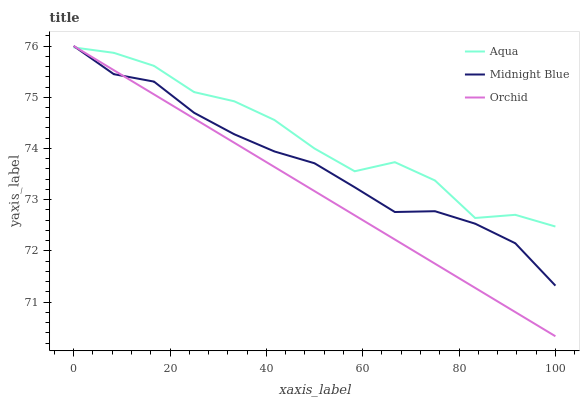Does Orchid have the minimum area under the curve?
Answer yes or no. Yes. Does Aqua have the maximum area under the curve?
Answer yes or no. Yes. Does Midnight Blue have the minimum area under the curve?
Answer yes or no. No. Does Midnight Blue have the maximum area under the curve?
Answer yes or no. No. Is Orchid the smoothest?
Answer yes or no. Yes. Is Aqua the roughest?
Answer yes or no. Yes. Is Midnight Blue the smoothest?
Answer yes or no. No. Is Midnight Blue the roughest?
Answer yes or no. No. Does Orchid have the lowest value?
Answer yes or no. Yes. Does Midnight Blue have the lowest value?
Answer yes or no. No. Does Orchid have the highest value?
Answer yes or no. Yes. Does Orchid intersect Midnight Blue?
Answer yes or no. Yes. Is Orchid less than Midnight Blue?
Answer yes or no. No. Is Orchid greater than Midnight Blue?
Answer yes or no. No. 